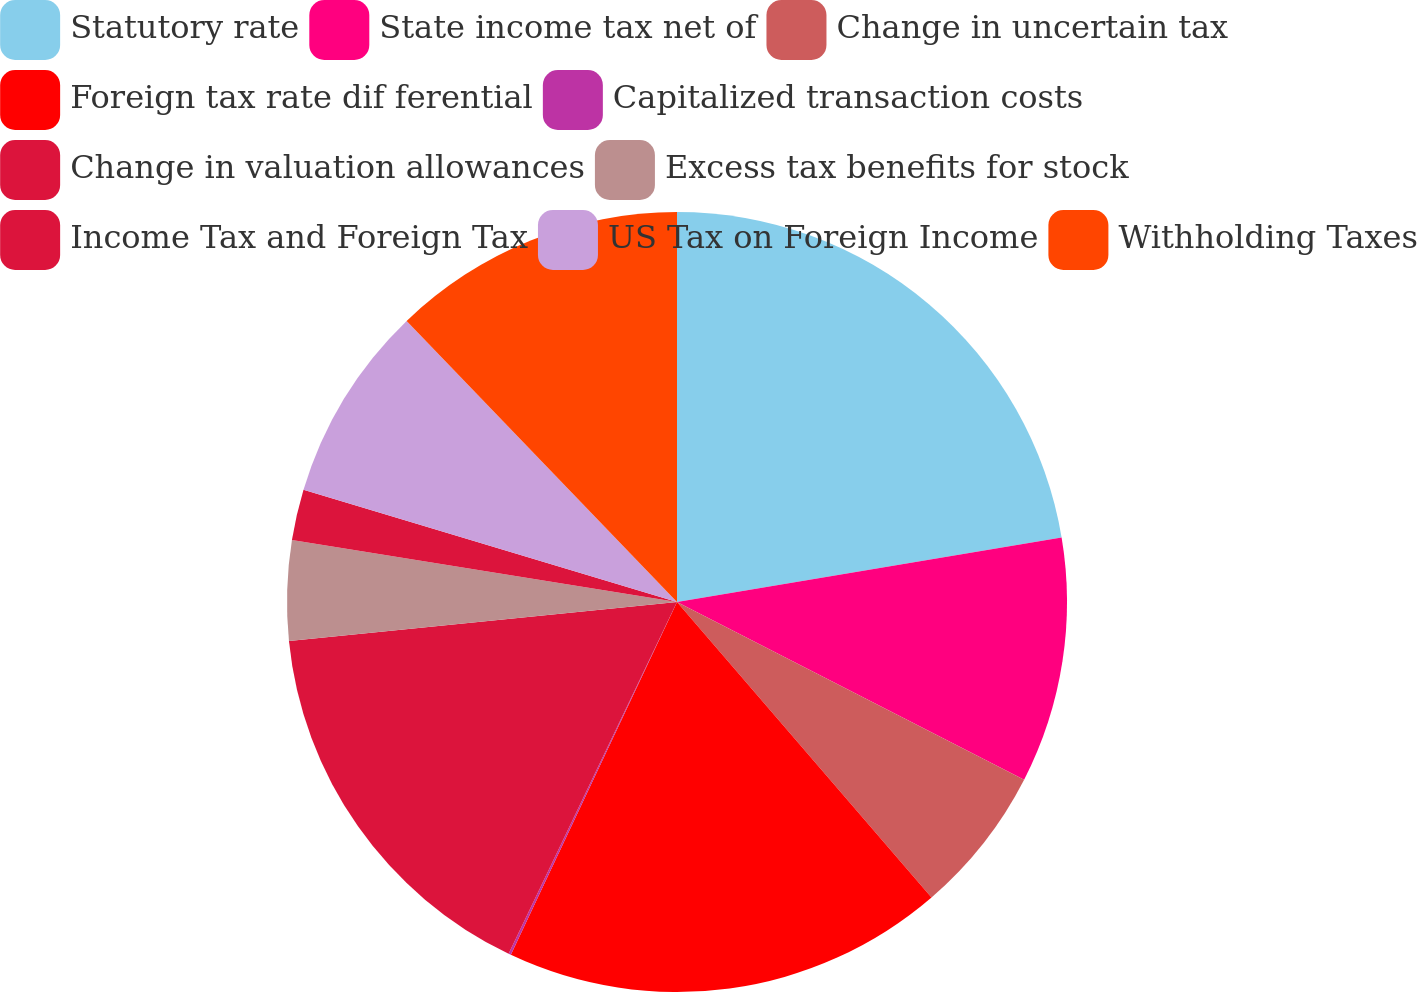Convert chart. <chart><loc_0><loc_0><loc_500><loc_500><pie_chart><fcel>Statutory rate<fcel>State income tax net of<fcel>Change in uncertain tax<fcel>Foreign tax rate dif ferential<fcel>Capitalized transaction costs<fcel>Change in valuation allowances<fcel>Excess tax benefits for stock<fcel>Income Tax and Foreign Tax<fcel>US Tax on Foreign Income<fcel>Withholding Taxes<nl><fcel>22.35%<fcel>10.18%<fcel>6.15%<fcel>18.32%<fcel>0.1%<fcel>16.3%<fcel>4.13%<fcel>2.11%<fcel>8.16%<fcel>12.19%<nl></chart> 